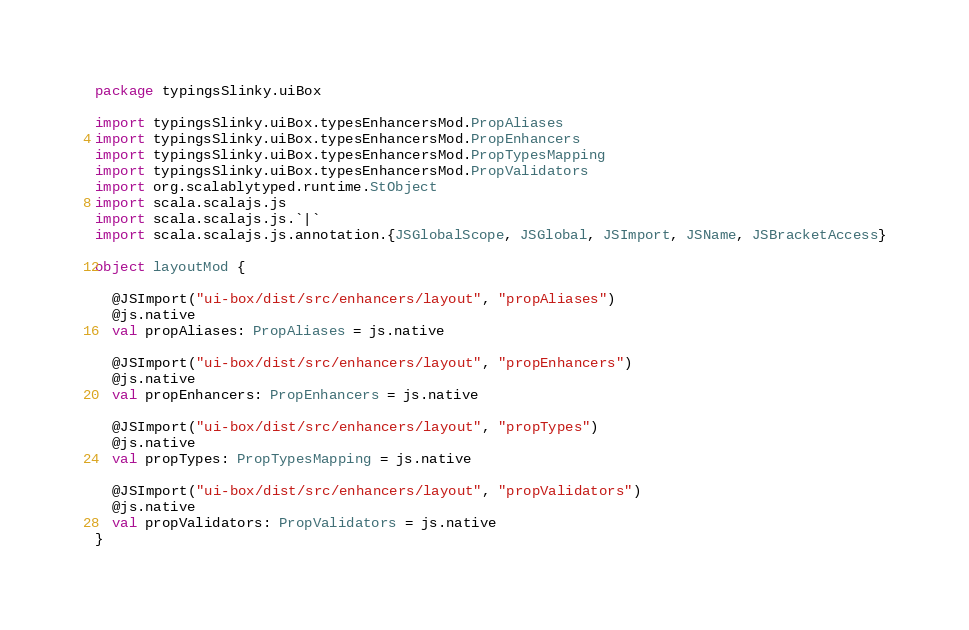Convert code to text. <code><loc_0><loc_0><loc_500><loc_500><_Scala_>package typingsSlinky.uiBox

import typingsSlinky.uiBox.typesEnhancersMod.PropAliases
import typingsSlinky.uiBox.typesEnhancersMod.PropEnhancers
import typingsSlinky.uiBox.typesEnhancersMod.PropTypesMapping
import typingsSlinky.uiBox.typesEnhancersMod.PropValidators
import org.scalablytyped.runtime.StObject
import scala.scalajs.js
import scala.scalajs.js.`|`
import scala.scalajs.js.annotation.{JSGlobalScope, JSGlobal, JSImport, JSName, JSBracketAccess}

object layoutMod {
  
  @JSImport("ui-box/dist/src/enhancers/layout", "propAliases")
  @js.native
  val propAliases: PropAliases = js.native
  
  @JSImport("ui-box/dist/src/enhancers/layout", "propEnhancers")
  @js.native
  val propEnhancers: PropEnhancers = js.native
  
  @JSImport("ui-box/dist/src/enhancers/layout", "propTypes")
  @js.native
  val propTypes: PropTypesMapping = js.native
  
  @JSImport("ui-box/dist/src/enhancers/layout", "propValidators")
  @js.native
  val propValidators: PropValidators = js.native
}
</code> 